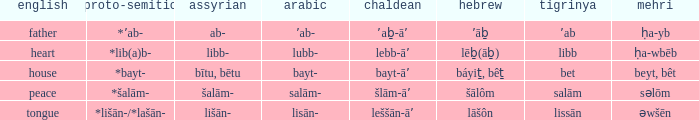Can you provide the hebrew equivalent for the word "heart" in english? Lēḇ(āḇ). 